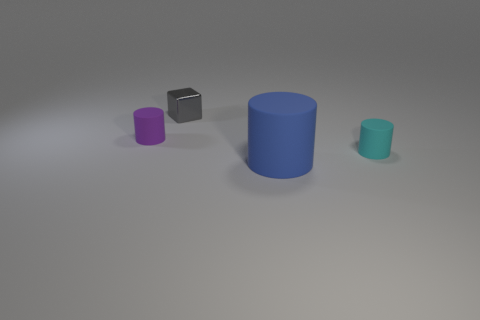Add 2 green shiny balls. How many objects exist? 6 Subtract all cubes. How many objects are left? 3 Add 2 large rubber spheres. How many large rubber spheres exist? 2 Subtract 0 brown balls. How many objects are left? 4 Subtract all small red things. Subtract all cyan cylinders. How many objects are left? 3 Add 2 cyan matte cylinders. How many cyan matte cylinders are left? 3 